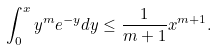Convert formula to latex. <formula><loc_0><loc_0><loc_500><loc_500>\int _ { 0 } ^ { x } y ^ { m } e ^ { - y } d y \leq \frac { 1 } { m + 1 } x ^ { m + 1 } .</formula> 